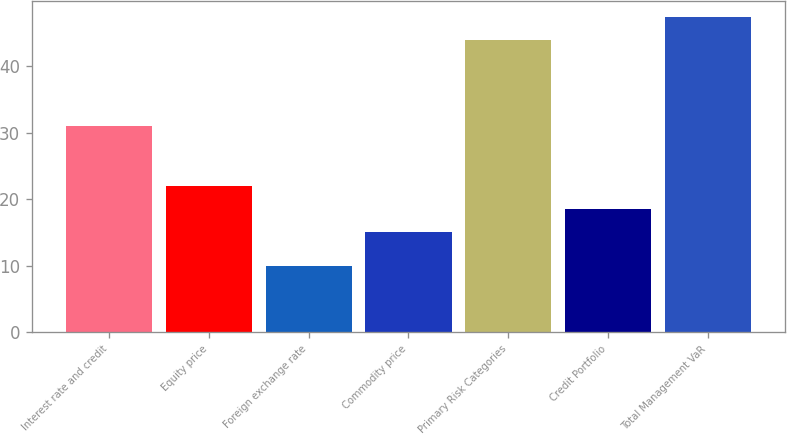Convert chart to OTSL. <chart><loc_0><loc_0><loc_500><loc_500><bar_chart><fcel>Interest rate and credit<fcel>Equity price<fcel>Foreign exchange rate<fcel>Commodity price<fcel>Primary Risk Categories<fcel>Credit Portfolio<fcel>Total Management VaR<nl><fcel>31<fcel>22<fcel>10<fcel>15<fcel>44<fcel>18.5<fcel>47.5<nl></chart> 